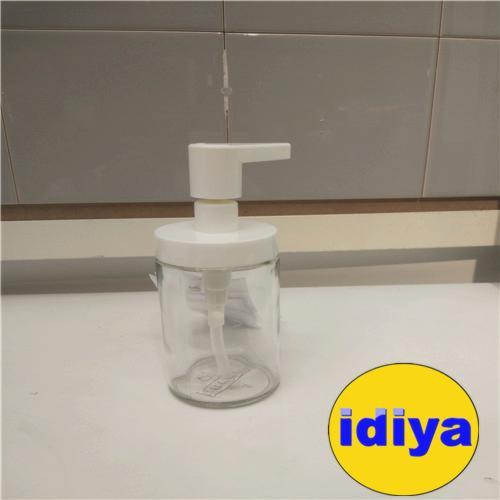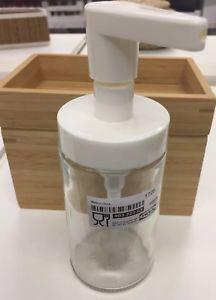The first image is the image on the left, the second image is the image on the right. For the images displayed, is the sentence "Each image includes at least one clear glass cylinder with a white pump top, but the pump nozzles in the left and right images face opposite directions." factually correct? Answer yes or no. No. The first image is the image on the left, the second image is the image on the right. Considering the images on both sides, is "There are exactly two dispensers." valid? Answer yes or no. Yes. 